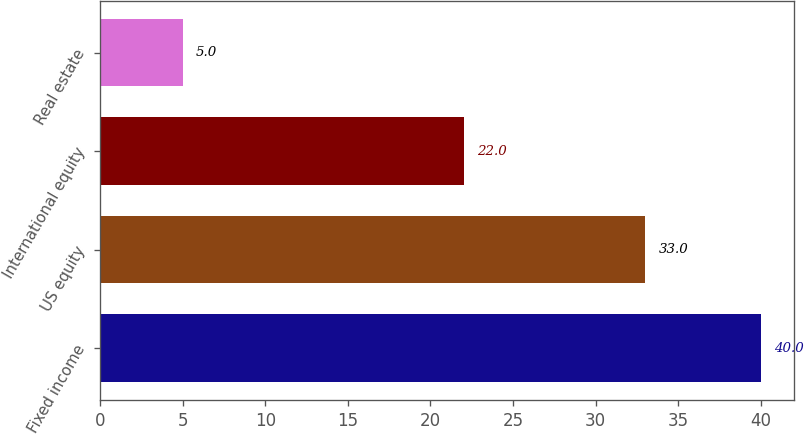Convert chart. <chart><loc_0><loc_0><loc_500><loc_500><bar_chart><fcel>Fixed income<fcel>US equity<fcel>International equity<fcel>Real estate<nl><fcel>40<fcel>33<fcel>22<fcel>5<nl></chart> 